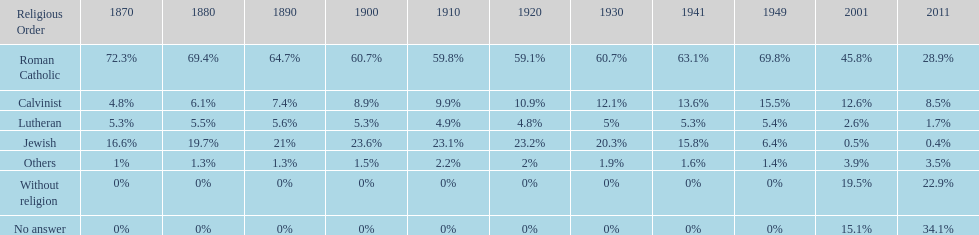How many denominations never dropped below 20%? 1. 